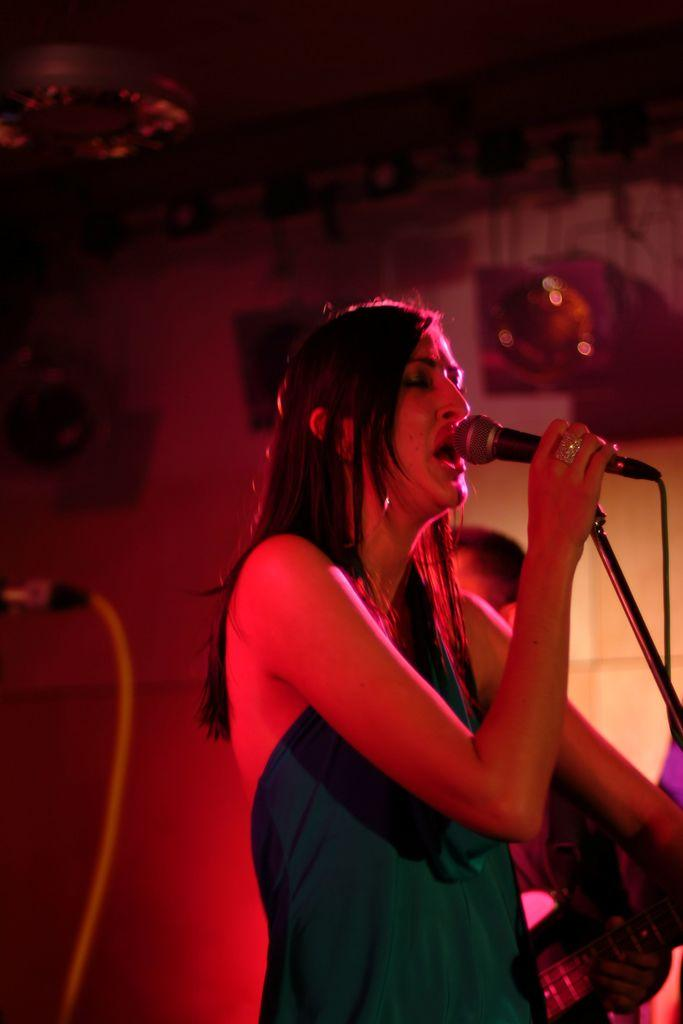Who is the main subject in the image? There is a woman in the image. What is the woman holding in the image? The woman is holding a microphone. What is the woman doing in the image? The woman is singing. What type of hat is the woman wearing in the image? There is no hat visible in the image; the woman is not wearing a hat. 